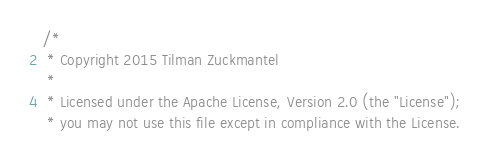Convert code to text. <code><loc_0><loc_0><loc_500><loc_500><_Scala_>/*
 * Copyright 2015 Tilman Zuckmantel
 *
 * Licensed under the Apache License, Version 2.0 (the "License");
 * you may not use this file except in compliance with the License.</code> 